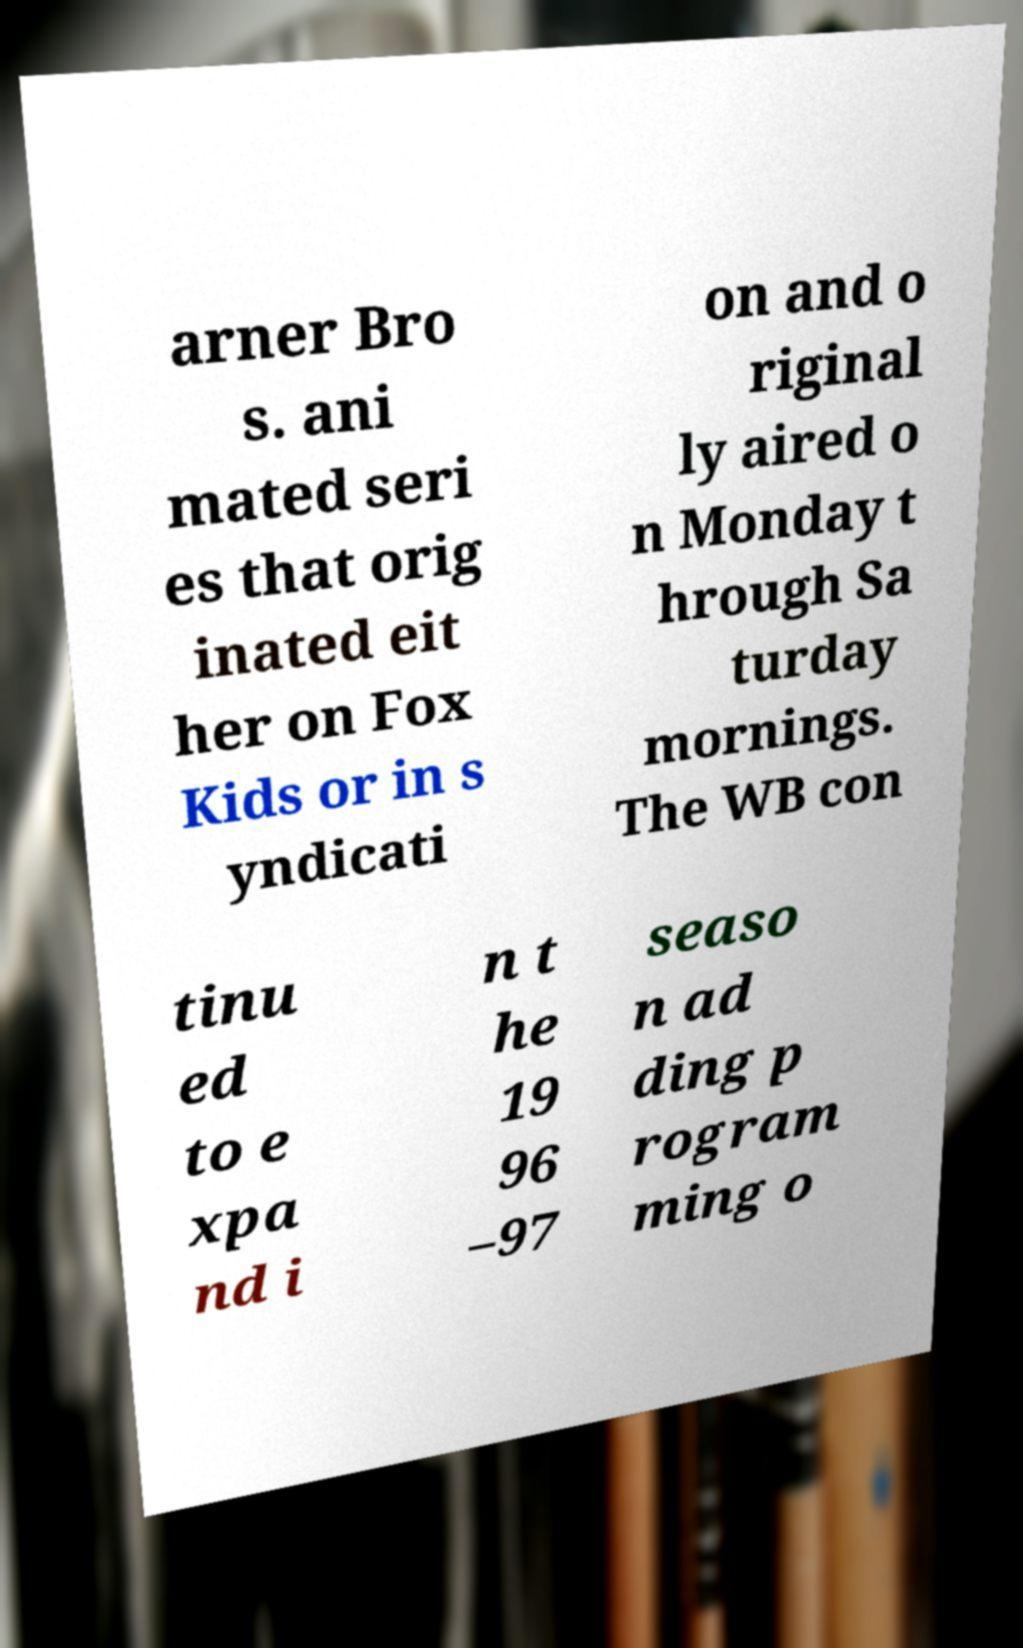Could you assist in decoding the text presented in this image and type it out clearly? arner Bro s. ani mated seri es that orig inated eit her on Fox Kids or in s yndicati on and o riginal ly aired o n Monday t hrough Sa turday mornings. The WB con tinu ed to e xpa nd i n t he 19 96 –97 seaso n ad ding p rogram ming o 